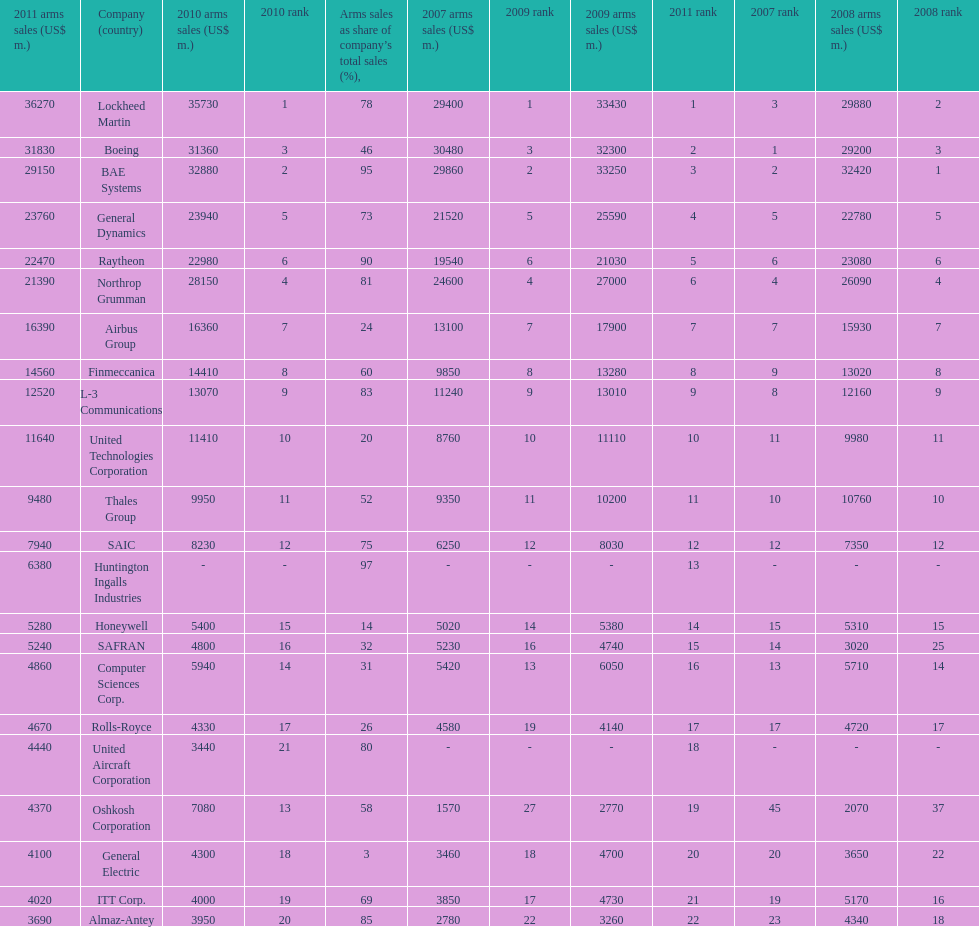Name all the companies whose arms sales as share of company's total sales is below 75%. Boeing, General Dynamics, Airbus Group, Finmeccanica, United Technologies Corporation, Thales Group, Honeywell, SAFRAN, Computer Sciences Corp., Rolls-Royce, Oshkosh Corporation, General Electric, ITT Corp. 